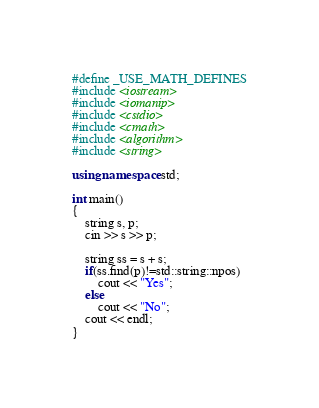<code> <loc_0><loc_0><loc_500><loc_500><_C++_>#define _USE_MATH_DEFINES
#include <iostream>
#include <iomanip>
#include <cstdio>
#include <cmath>
#include <algorithm>
#include <string>

using namespace std;

int main()
{
    string s, p;
    cin >> s >> p;

    string ss = s + s;
    if(ss.find(p)!=std::string::npos)
        cout << "Yes";
    else
        cout << "No";
    cout << endl;
}
</code> 